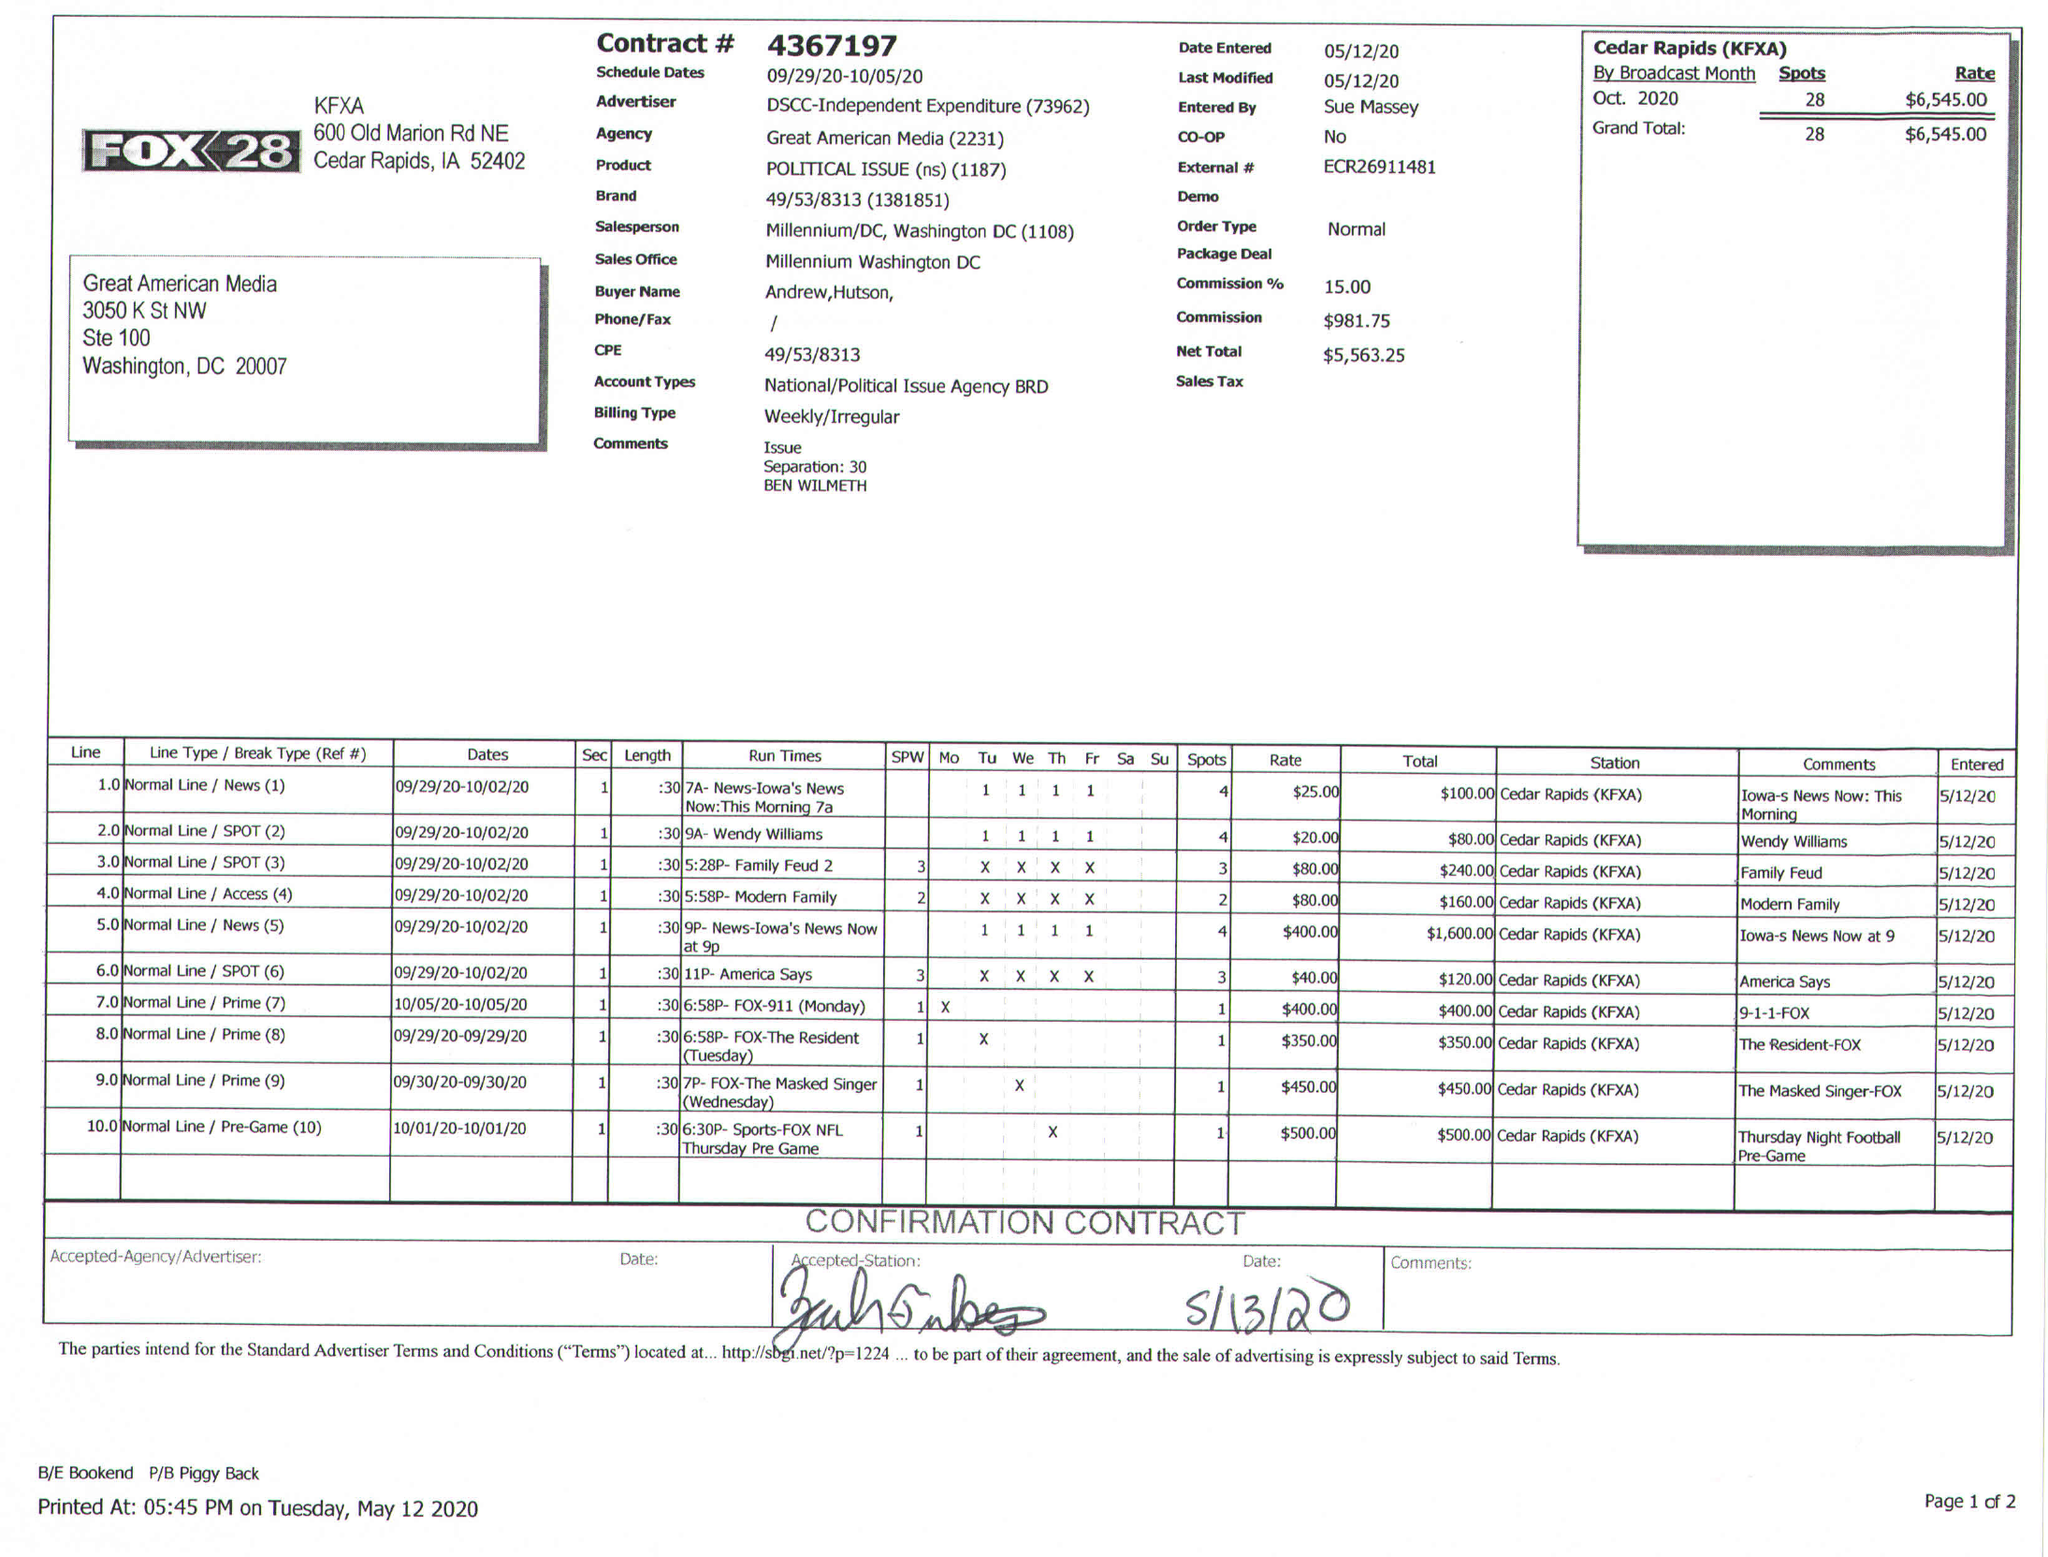What is the value for the flight_to?
Answer the question using a single word or phrase. 10/05/20 